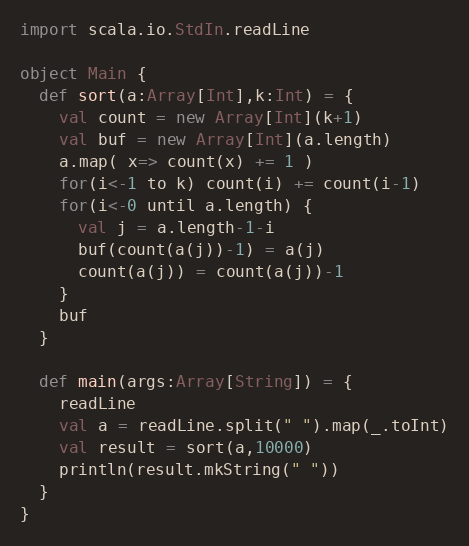<code> <loc_0><loc_0><loc_500><loc_500><_Scala_>import scala.io.StdIn.readLine

object Main {
  def sort(a:Array[Int],k:Int) = {
    val count = new Array[Int](k+1)
    val buf = new Array[Int](a.length)
    a.map( x=> count(x) += 1 )
    for(i<-1 to k) count(i) += count(i-1)
    for(i<-0 until a.length) {
      val j = a.length-1-i
      buf(count(a(j))-1) = a(j)
      count(a(j)) = count(a(j))-1
    }
    buf
  }

  def main(args:Array[String]) = {
    readLine
    val a = readLine.split(" ").map(_.toInt)
    val result = sort(a,10000)
    println(result.mkString(" "))
  }
}</code> 